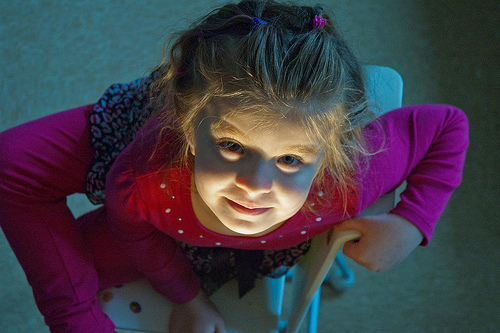<image>
Can you confirm if the child is to the left of the light? No. The child is not to the left of the light. From this viewpoint, they have a different horizontal relationship. 